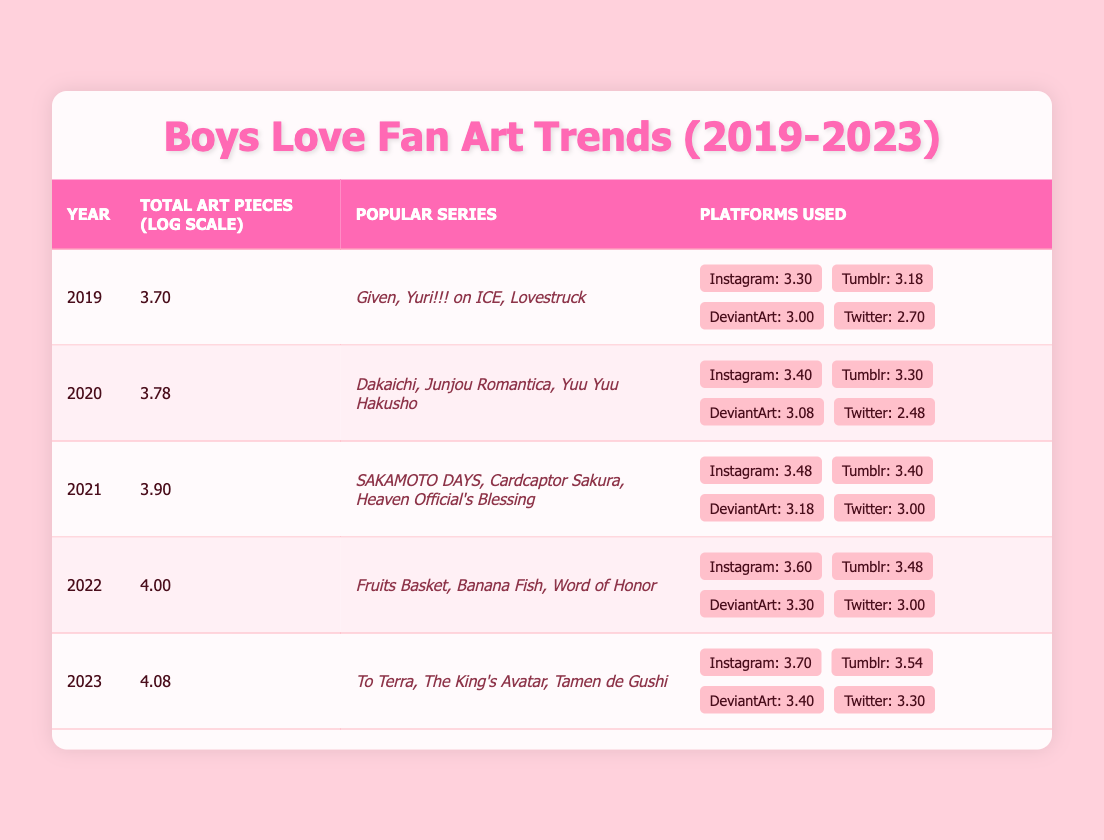What was the total number of fan art pieces in 2022? According to the table, the total art pieces for the year 2022 is stated directly in the "Total Art Pieces" column as 10000.
Answer: 10000 Which platform saw the highest number of art pieces in 2023? In 2023, the number of art pieces per platform lists Instagram as having 5000 pieces, which is greater than any other platform's counts.
Answer: Instagram What was the increase in total art pieces from 2019 to 2023? Total art pieces in 2019 was 5000 and in 2023 it is 12000. The increase is calculated as 12000 - 5000 = 7000.
Answer: 7000 Did the popularity of Tumblr as a platform for fan art increase from 2020 to 2021? In 2020, Tumblr had 2000 pieces and in 2021, it had 2500 pieces. Since 2500 is greater than 2000, this indicates an increase in popularity.
Answer: Yes What was the average number of fan art pieces from 2019 to 2023? To find the average, sum the total art pieces from each year: 5000 + 6000 + 8000 + 10000 + 12000 = 40000. Then divide by the number of years, which is 5. Thus, the average is 40000 / 5 = 8000.
Answer: 8000 Which year had the highest logarithmic value for total art pieces, and what was that value? By examining the table, 2023 has the highest logarithmic value of 4.08, which is clearly stated in the "Total Art Pieces (Log Scale)" column.
Answer: 4.08 What was the most popular series in 2021? The table lists the popular series for 2021 as "SAKAMOTO DAYS, Cardcaptor Sakura, Heaven Official's Blessing," which can be found in the "Popular Series" column corresponding to the year 2021.
Answer: SAKAMOTO DAYS, Cardcaptor Sakura, Heaven Official's Blessing Was there a decline in the number of art pieces on Twitter from 2020 to 2021? In 2020, Twitter had 300 art pieces then increased to 1000 in 2021. Since 1000 is greater than 300, this indicates an increase rather than a decline.
Answer: No What was the total number of art pieces across all platforms in 2022? Calculating the total across all platforms in 2022 includes Instagram (4000), Tumblr (3000), DeviantArt (2000), and Twitter (1000). The total is thus 4000 + 3000 + 2000 + 1000 = 10000.
Answer: 10000 